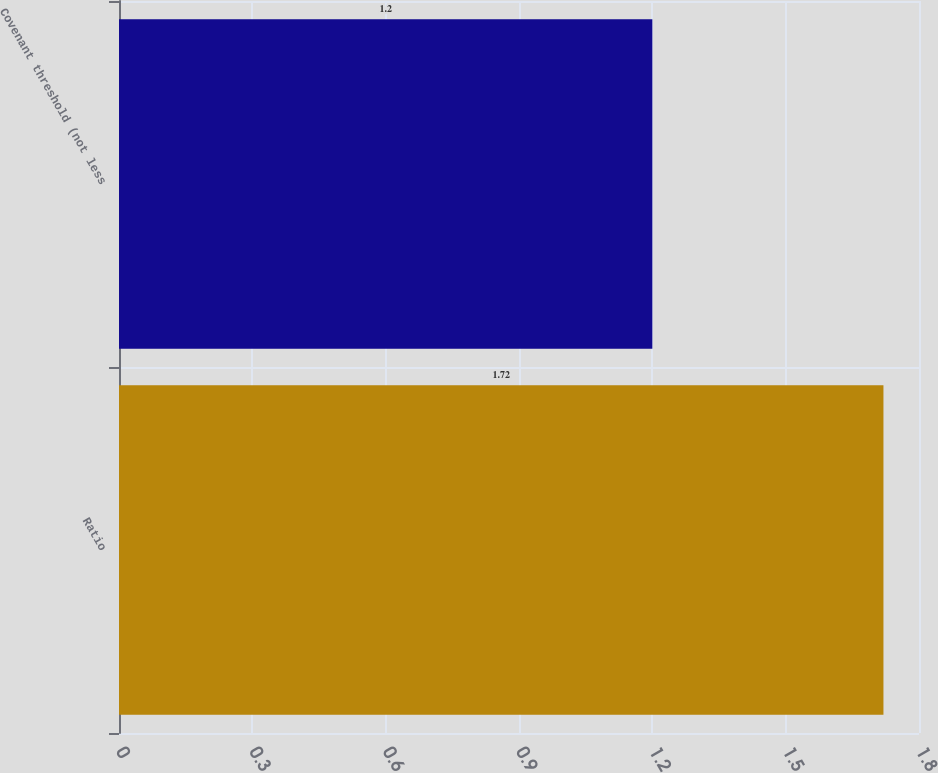Convert chart to OTSL. <chart><loc_0><loc_0><loc_500><loc_500><bar_chart><fcel>Ratio<fcel>Covenant threshold (not less<nl><fcel>1.72<fcel>1.2<nl></chart> 